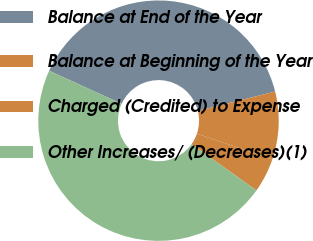Convert chart to OTSL. <chart><loc_0><loc_0><loc_500><loc_500><pie_chart><fcel>Balance at End of the Year<fcel>Balance at Beginning of the Year<fcel>Charged (Credited) to Expense<fcel>Other Increases/ (Decreases)(1)<nl><fcel>39.28%<fcel>9.1%<fcel>4.65%<fcel>46.96%<nl></chart> 